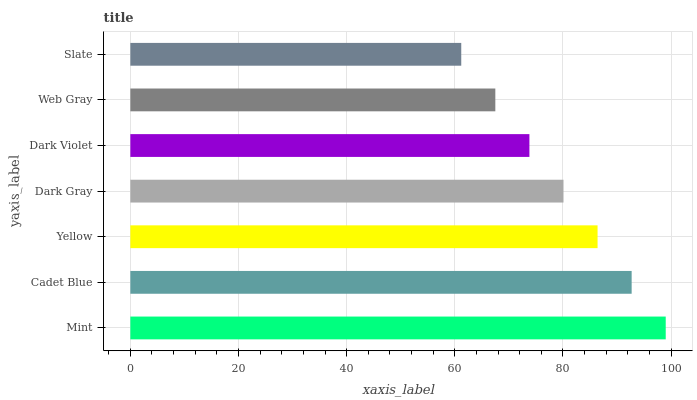Is Slate the minimum?
Answer yes or no. Yes. Is Mint the maximum?
Answer yes or no. Yes. Is Cadet Blue the minimum?
Answer yes or no. No. Is Cadet Blue the maximum?
Answer yes or no. No. Is Mint greater than Cadet Blue?
Answer yes or no. Yes. Is Cadet Blue less than Mint?
Answer yes or no. Yes. Is Cadet Blue greater than Mint?
Answer yes or no. No. Is Mint less than Cadet Blue?
Answer yes or no. No. Is Dark Gray the high median?
Answer yes or no. Yes. Is Dark Gray the low median?
Answer yes or no. Yes. Is Mint the high median?
Answer yes or no. No. Is Yellow the low median?
Answer yes or no. No. 